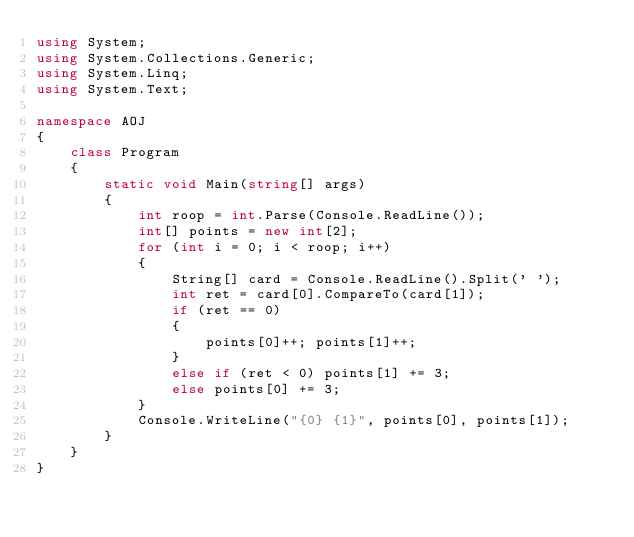<code> <loc_0><loc_0><loc_500><loc_500><_C#_>using System;
using System.Collections.Generic;
using System.Linq;
using System.Text;

namespace AOJ
{
    class Program
    {
        static void Main(string[] args)
        {
            int roop = int.Parse(Console.ReadLine());
            int[] points = new int[2];
            for (int i = 0; i < roop; i++)
            {
                String[] card = Console.ReadLine().Split(' ');
                int ret = card[0].CompareTo(card[1]);
                if (ret == 0)
                {
                    points[0]++; points[1]++;
                }
                else if (ret < 0) points[1] += 3;
                else points[0] += 3;
            }
            Console.WriteLine("{0} {1}", points[0], points[1]);
        }
    }
}</code> 